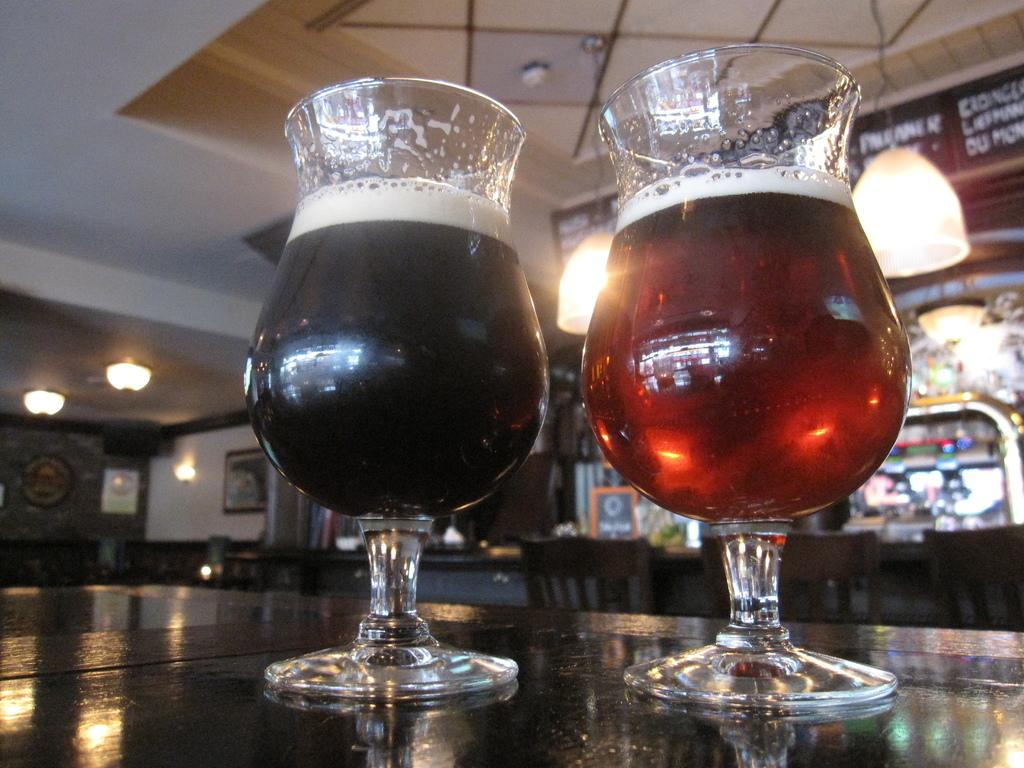What objects are on the table in the image? There are glasses on the table in the image. What type of lighting is present in the room? There are lights hanging from the ceiling and other lights on the left side of the image. What type of yoke is used to hold the glasses on the table? There is no yoke present in the image; the glasses are simply placed on the table. What time of day is it in the image, considering the lighting? The time of day cannot be determined from the lighting in the image alone, as both artificial and natural light sources are present. 